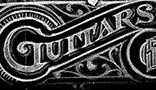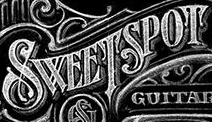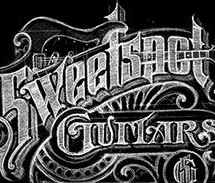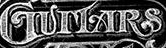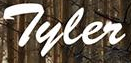What text is displayed in these images sequentially, separated by a semicolon? GUITARS; SWEETSPOT; Sweetspot; GUITARS; Tyler 